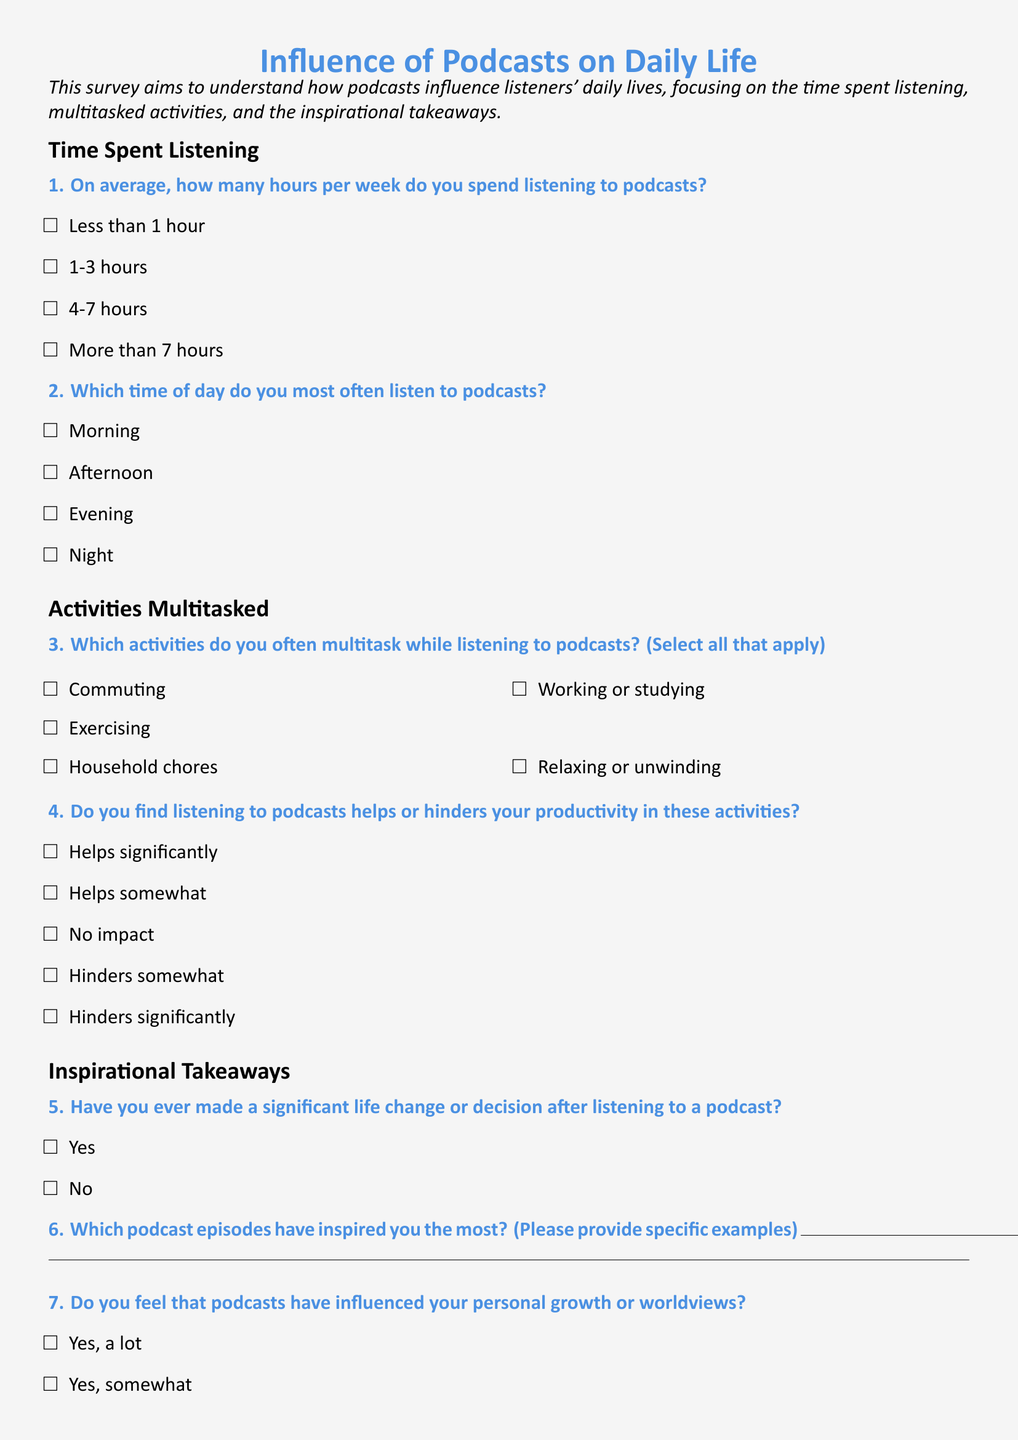What is the purpose of the survey? The survey aims to understand how podcasts influence listeners' daily lives, focusing on time spent listening, multitasked activities, and inspirational takeaways.
Answer: To understand the influence of podcasts on daily life How many questions are there in the survey? The survey consists of seven questions related to time spent listening, multitasked activities, and inspirational takeaways.
Answer: Seven What is the first activity listed for multitasking while listening to podcasts? The first activity listed for multitasking is "Commuting," among other activities.
Answer: Commuting What response option indicates a significant impact on productivity? The option that indicates significant help to productivity is "Helps significantly."
Answer: Helps significantly Do podcasts influence personal growth, according to this survey? The survey asks respondents if they feel podcasts influence their personal growth, with options ranging from "Yes, a lot" to "No, not at all."
Answer: Yes, a lot 